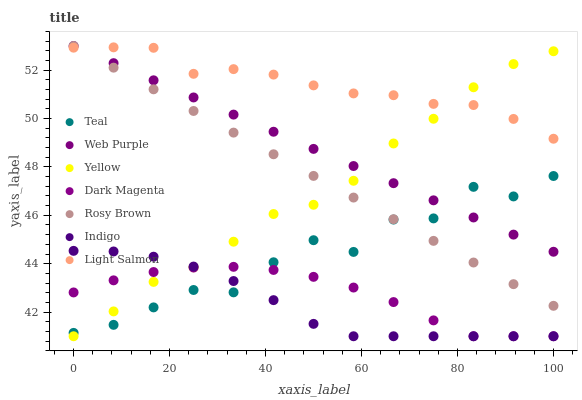Does Indigo have the minimum area under the curve?
Answer yes or no. Yes. Does Light Salmon have the maximum area under the curve?
Answer yes or no. Yes. Does Dark Magenta have the minimum area under the curve?
Answer yes or no. No. Does Dark Magenta have the maximum area under the curve?
Answer yes or no. No. Is Web Purple the smoothest?
Answer yes or no. Yes. Is Teal the roughest?
Answer yes or no. Yes. Is Indigo the smoothest?
Answer yes or no. No. Is Indigo the roughest?
Answer yes or no. No. Does Indigo have the lowest value?
Answer yes or no. Yes. Does Rosy Brown have the lowest value?
Answer yes or no. No. Does Web Purple have the highest value?
Answer yes or no. Yes. Does Indigo have the highest value?
Answer yes or no. No. Is Teal less than Light Salmon?
Answer yes or no. Yes. Is Web Purple greater than Dark Magenta?
Answer yes or no. Yes. Does Rosy Brown intersect Teal?
Answer yes or no. Yes. Is Rosy Brown less than Teal?
Answer yes or no. No. Is Rosy Brown greater than Teal?
Answer yes or no. No. Does Teal intersect Light Salmon?
Answer yes or no. No. 